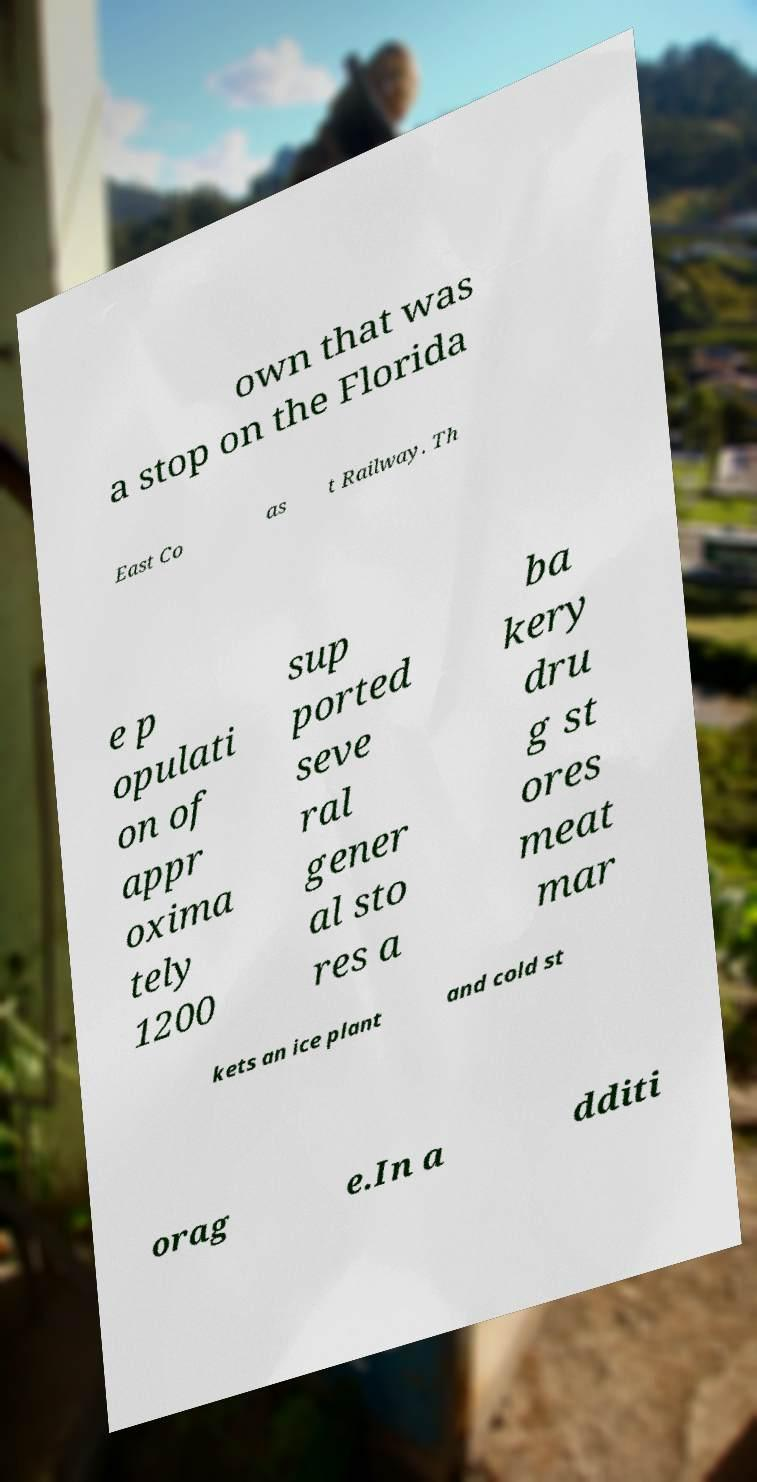Could you extract and type out the text from this image? own that was a stop on the Florida East Co as t Railway. Th e p opulati on of appr oxima tely 1200 sup ported seve ral gener al sto res a ba kery dru g st ores meat mar kets an ice plant and cold st orag e.In a dditi 